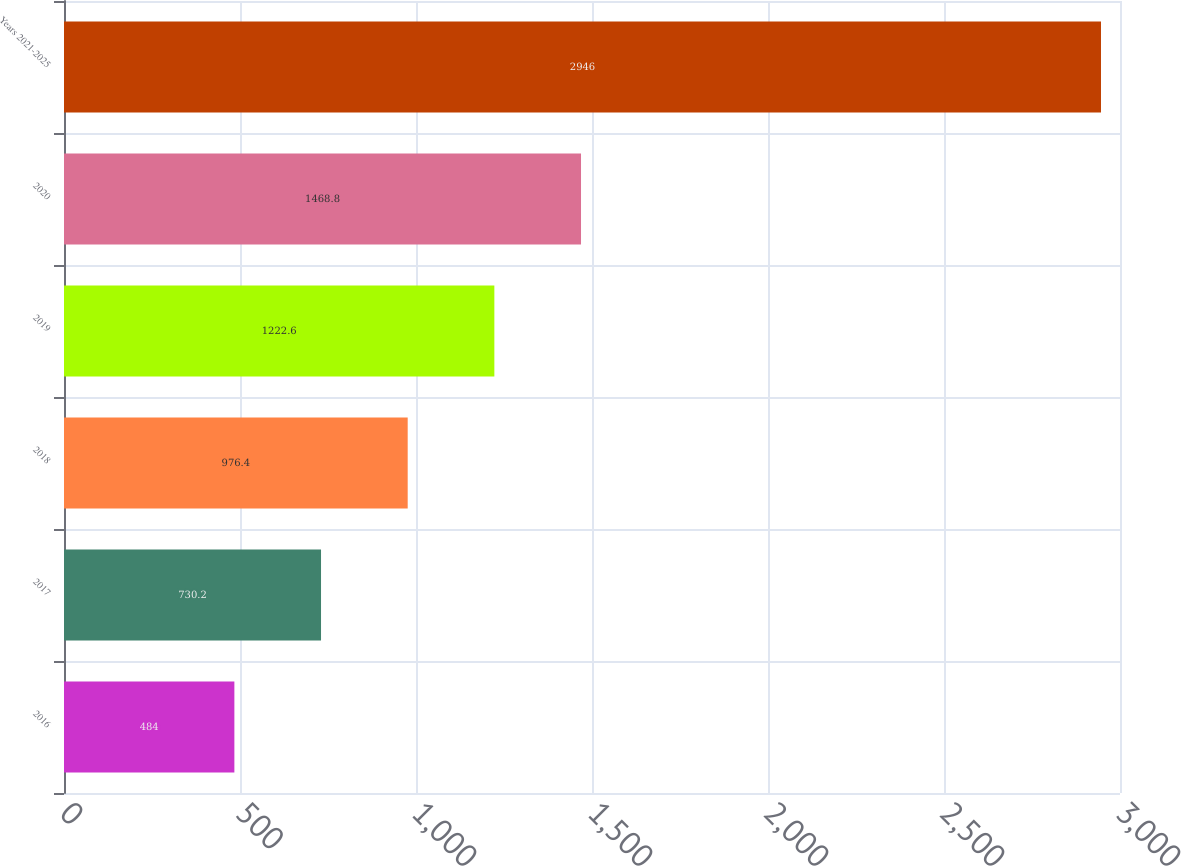Convert chart to OTSL. <chart><loc_0><loc_0><loc_500><loc_500><bar_chart><fcel>2016<fcel>2017<fcel>2018<fcel>2019<fcel>2020<fcel>Years 2021-­2025<nl><fcel>484<fcel>730.2<fcel>976.4<fcel>1222.6<fcel>1468.8<fcel>2946<nl></chart> 